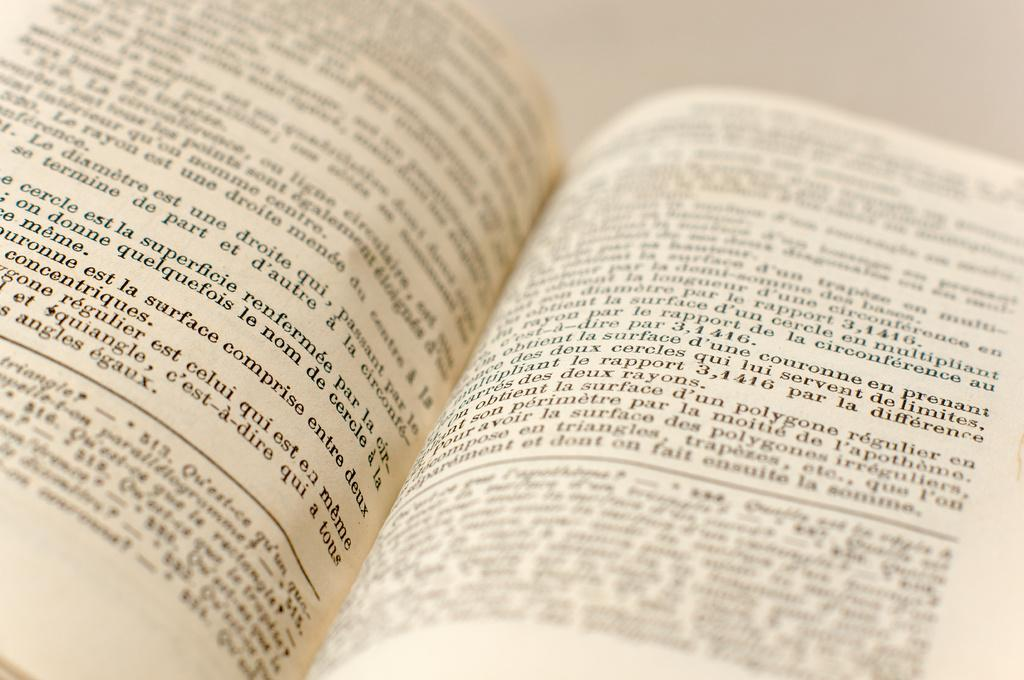<image>
Present a compact description of the photo's key features. A book is open to a page that says est la surface comprise entre duex. 